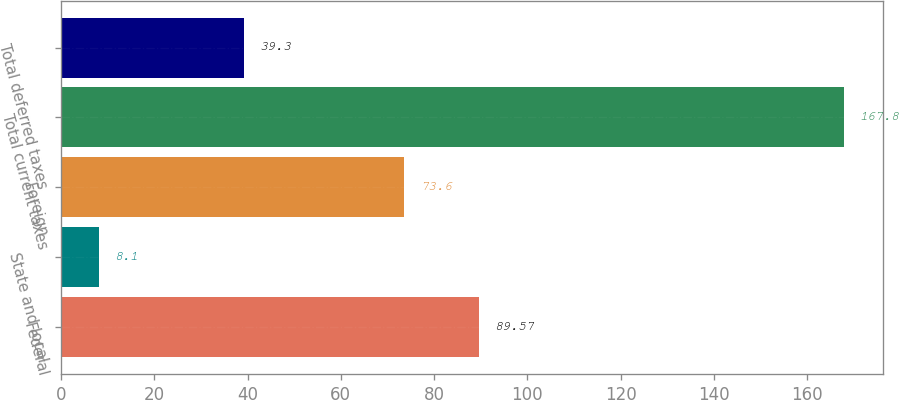<chart> <loc_0><loc_0><loc_500><loc_500><bar_chart><fcel>Federal<fcel>State and local<fcel>Foreign<fcel>Total current taxes<fcel>Total deferred taxes<nl><fcel>89.57<fcel>8.1<fcel>73.6<fcel>167.8<fcel>39.3<nl></chart> 